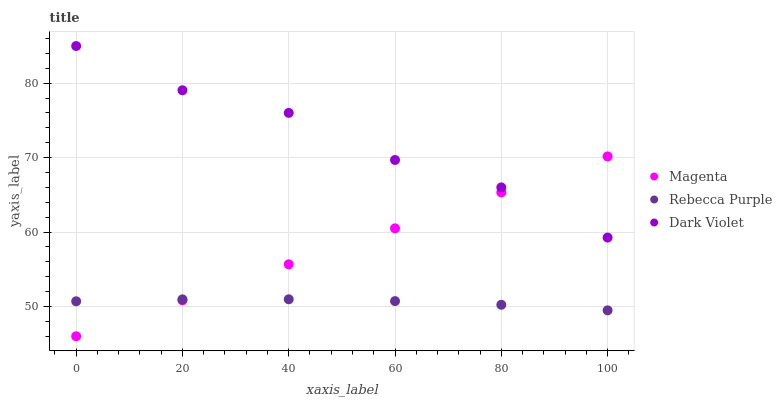Does Rebecca Purple have the minimum area under the curve?
Answer yes or no. Yes. Does Dark Violet have the maximum area under the curve?
Answer yes or no. Yes. Does Dark Violet have the minimum area under the curve?
Answer yes or no. No. Does Rebecca Purple have the maximum area under the curve?
Answer yes or no. No. Is Magenta the smoothest?
Answer yes or no. Yes. Is Dark Violet the roughest?
Answer yes or no. Yes. Is Rebecca Purple the smoothest?
Answer yes or no. No. Is Rebecca Purple the roughest?
Answer yes or no. No. Does Magenta have the lowest value?
Answer yes or no. Yes. Does Rebecca Purple have the lowest value?
Answer yes or no. No. Does Dark Violet have the highest value?
Answer yes or no. Yes. Does Rebecca Purple have the highest value?
Answer yes or no. No. Is Rebecca Purple less than Dark Violet?
Answer yes or no. Yes. Is Dark Violet greater than Rebecca Purple?
Answer yes or no. Yes. Does Dark Violet intersect Magenta?
Answer yes or no. Yes. Is Dark Violet less than Magenta?
Answer yes or no. No. Is Dark Violet greater than Magenta?
Answer yes or no. No. Does Rebecca Purple intersect Dark Violet?
Answer yes or no. No. 